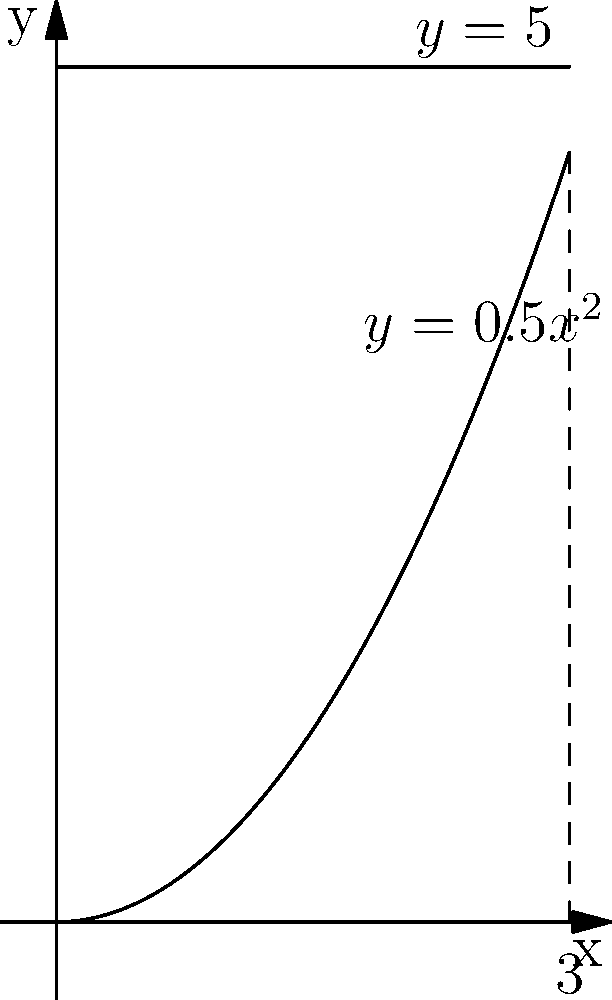As the city council member proposing the skate park, you need to calculate the volume of concrete required for the bowl feature. The cross-section of the bowl can be modeled by rotating the region bounded by $y=0.5x^2$ and $y=5$ about the y-axis from $x=0$ to $x=3$. Calculate the volume of concrete needed for this bowl feature. To find the volume of the bowl, we need to use the washer method of integration:

1) The volume is given by the formula:
   $$V = \pi \int_0^3 (R(x)^2 - r(x)^2) dx$$
   where $R(x)$ is the outer radius and $r(x)$ is the inner radius.

2) In this case, $R(x) = 3$ (constant outer radius) and $r(x) = x$ (inner radius varies with x).

3) Substituting these into our formula:
   $$V = \pi \int_0^3 (3^2 - x^2) dx$$

4) Simplify:
   $$V = \pi \int_0^3 (9 - x^2) dx$$

5) Integrate:
   $$V = \pi [9x - \frac{1}{3}x^3]_0^3$$

6) Evaluate the integral:
   $$V = \pi [(27 - 9) - (0 - 0)] = 18\pi$$

7) The volume is in cubic units. Assuming our measurements are in meters, the final volume is $18\pi$ cubic meters.
Answer: $18\pi$ cubic meters 